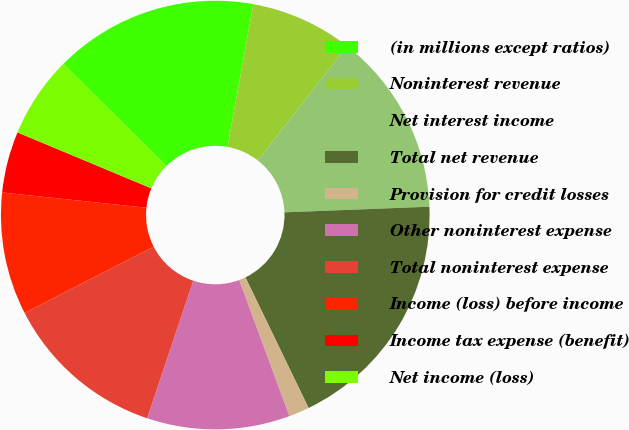Convert chart. <chart><loc_0><loc_0><loc_500><loc_500><pie_chart><fcel>(in millions except ratios)<fcel>Noninterest revenue<fcel>Net interest income<fcel>Total net revenue<fcel>Provision for credit losses<fcel>Other noninterest expense<fcel>Total noninterest expense<fcel>Income (loss) before income<fcel>Income tax expense (benefit)<fcel>Net income (loss)<nl><fcel>15.38%<fcel>7.7%<fcel>13.84%<fcel>18.45%<fcel>1.55%<fcel>10.77%<fcel>12.3%<fcel>9.23%<fcel>4.62%<fcel>6.16%<nl></chart> 